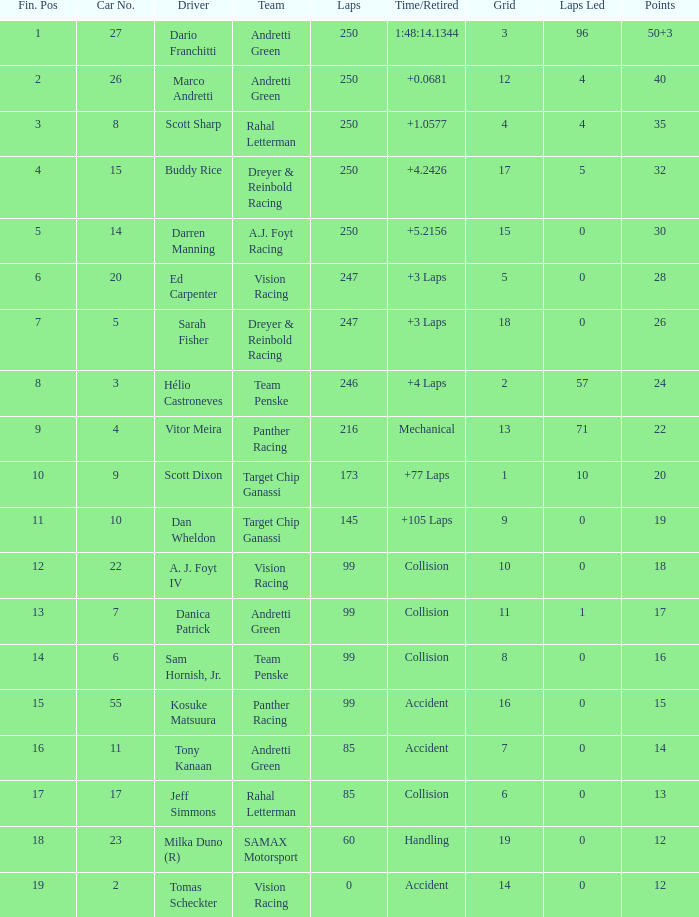What is the grid for the driver who earned 14 points? 7.0. 